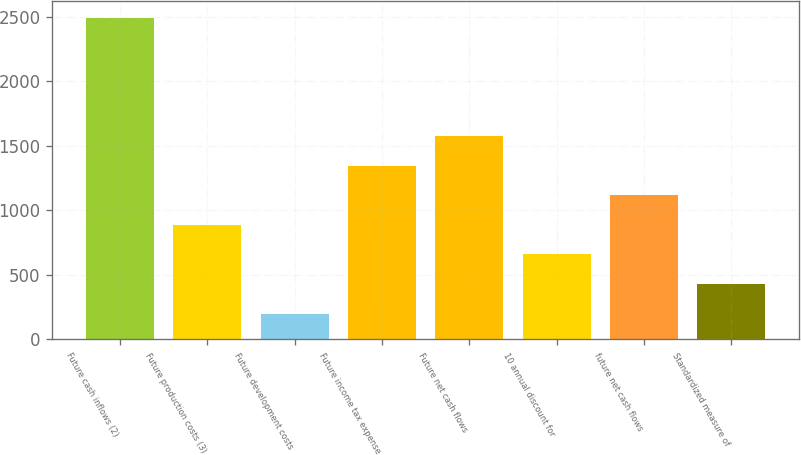Convert chart. <chart><loc_0><loc_0><loc_500><loc_500><bar_chart><fcel>Future cash inflows (2)<fcel>Future production costs (3)<fcel>Future development costs<fcel>Future income tax expense<fcel>Future net cash flows<fcel>10 annual discount for<fcel>future net cash flows<fcel>Standardized measure of<nl><fcel>2492<fcel>887.6<fcel>200<fcel>1346<fcel>1575.2<fcel>658.4<fcel>1116.8<fcel>429.2<nl></chart> 